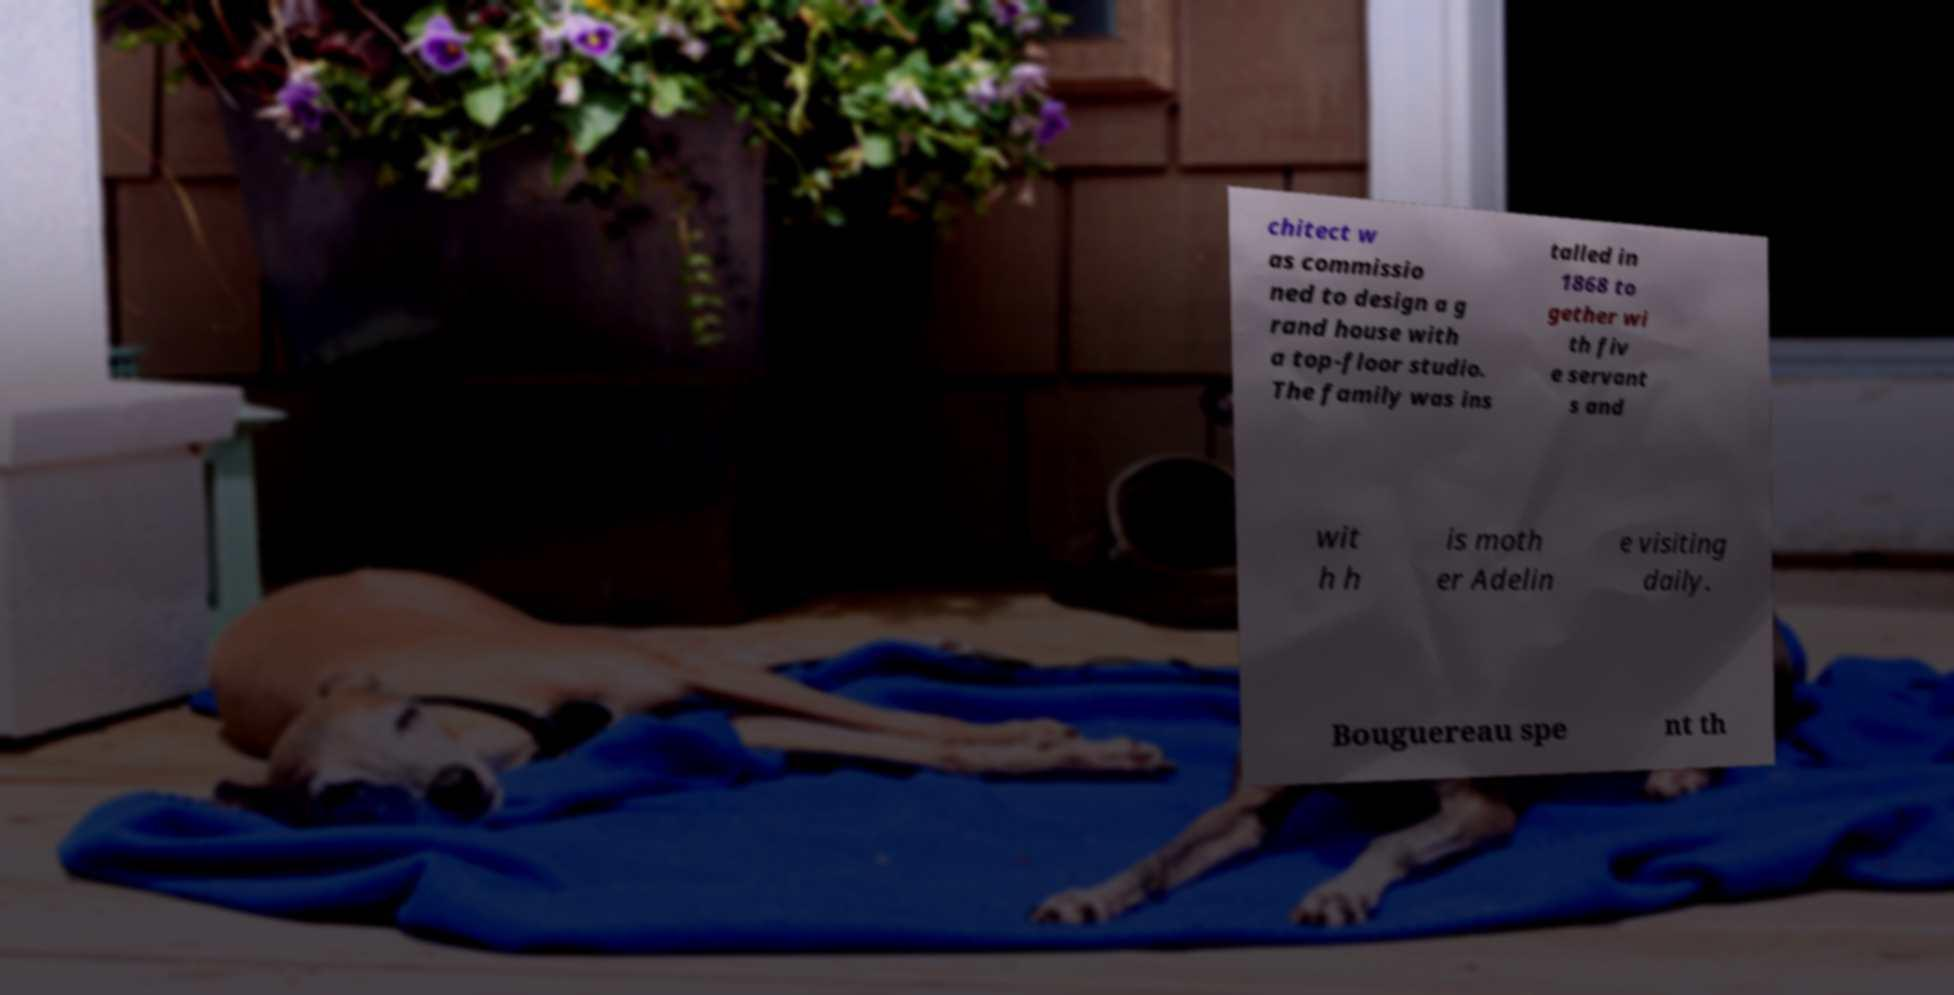Please read and relay the text visible in this image. What does it say? chitect w as commissio ned to design a g rand house with a top-floor studio. The family was ins talled in 1868 to gether wi th fiv e servant s and wit h h is moth er Adelin e visiting daily. Bouguereau spe nt th 